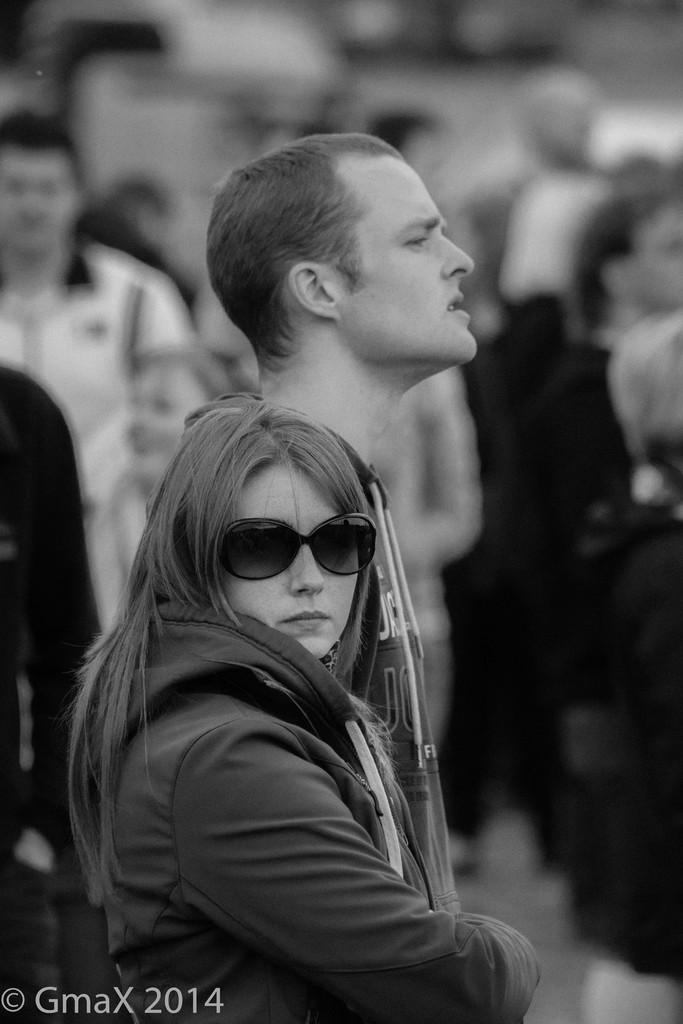What type of picture is in the image? The image contains a black and white picture. What can be seen in the picture? The picture depicts people wearing clothes. Is there any text or marking on the image? Yes, there is a watermark on the bottom left of the image. How would you describe the background of the picture? The background of the image is blurred. Can you see any slopes or snakes in the garden in the image? There is no garden present in the image, so it is not possible to see any slopes or snakes. 